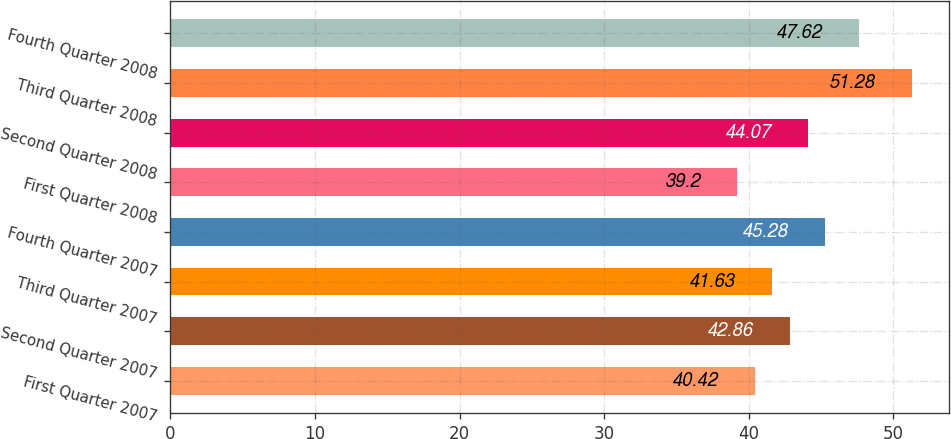<chart> <loc_0><loc_0><loc_500><loc_500><bar_chart><fcel>First Quarter 2007<fcel>Second Quarter 2007<fcel>Third Quarter 2007<fcel>Fourth Quarter 2007<fcel>First Quarter 2008<fcel>Second Quarter 2008<fcel>Third Quarter 2008<fcel>Fourth Quarter 2008<nl><fcel>40.42<fcel>42.86<fcel>41.63<fcel>45.28<fcel>39.2<fcel>44.07<fcel>51.28<fcel>47.62<nl></chart> 